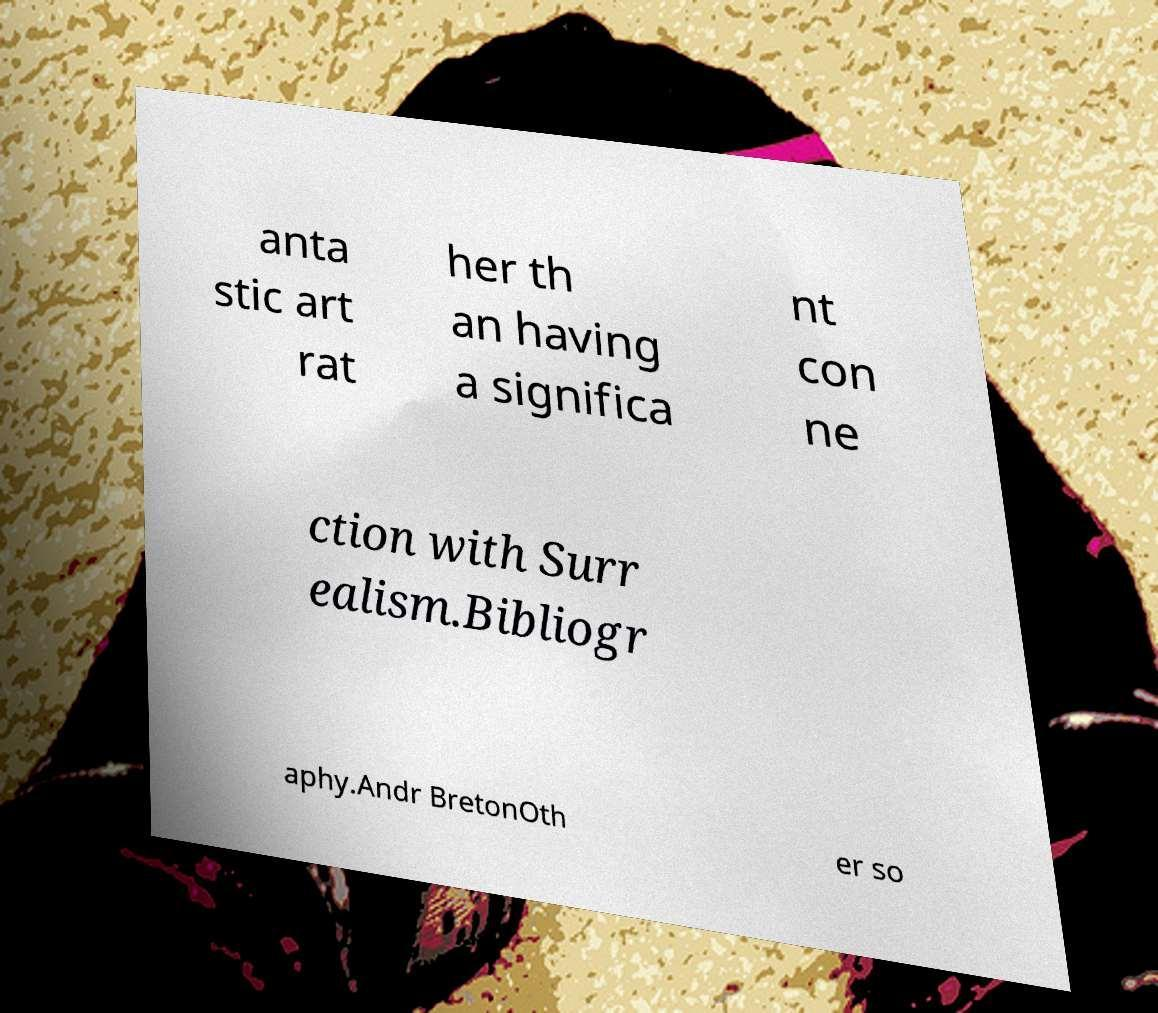Can you accurately transcribe the text from the provided image for me? anta stic art rat her th an having a significa nt con ne ction with Surr ealism.Bibliogr aphy.Andr BretonOth er so 